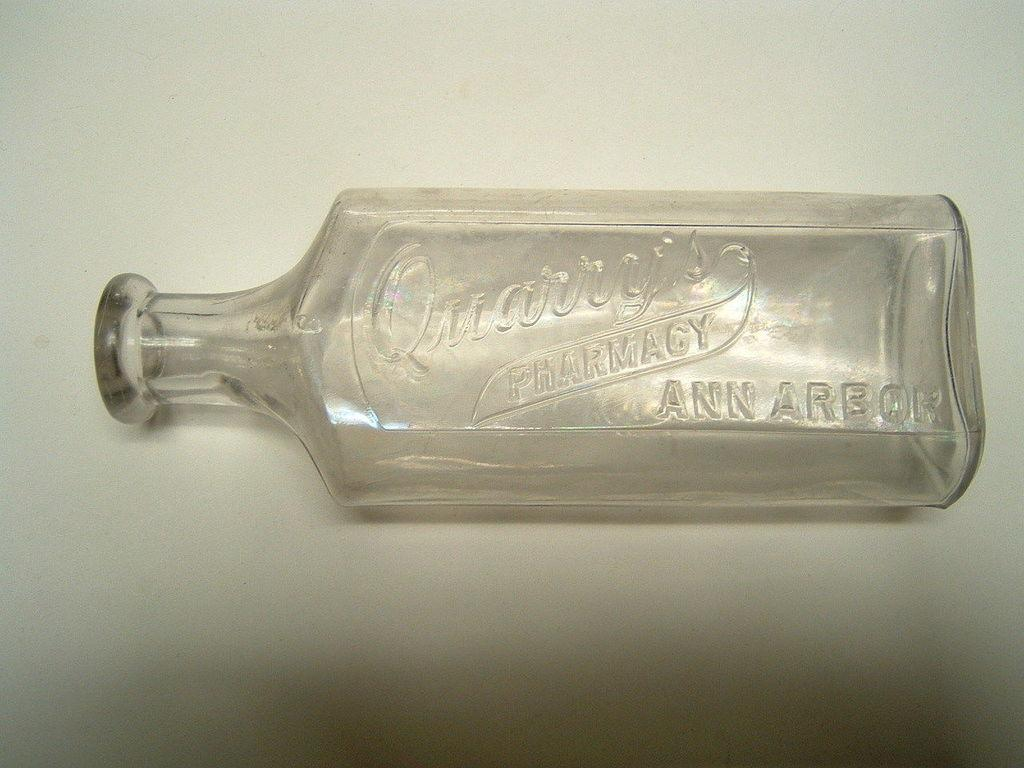What object is the main focus of the image? There is a glass bottle in the image. What is written on the glass bottle? The glass bottle has "pharmacy" written on it. What color is the background of the image? The background of the image is white. Can you see a kitten wearing trousers in the image? No, there is no kitten or any clothing present in the image. The image only features a glass bottle with "pharmacy" written on it against a white background. 